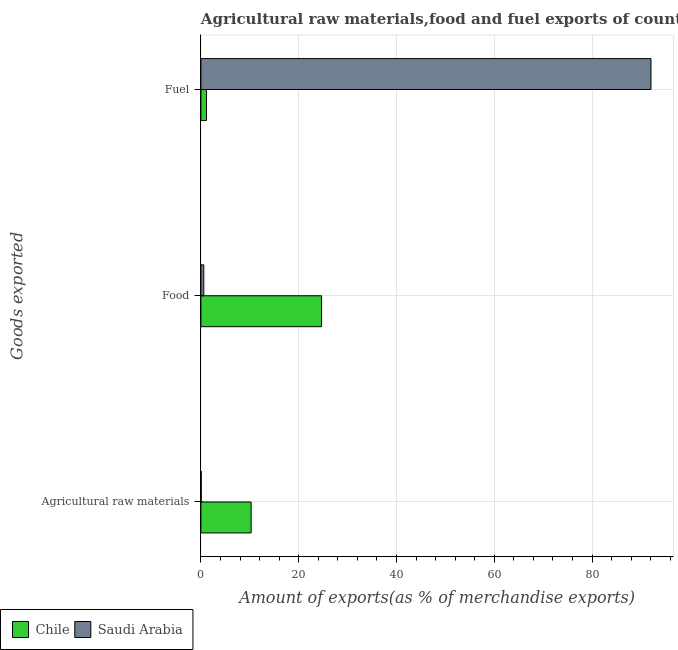How many bars are there on the 3rd tick from the top?
Make the answer very short. 2. How many bars are there on the 2nd tick from the bottom?
Offer a very short reply. 2. What is the label of the 1st group of bars from the top?
Keep it short and to the point. Fuel. What is the percentage of food exports in Saudi Arabia?
Make the answer very short. 0.59. Across all countries, what is the maximum percentage of fuel exports?
Your response must be concise. 92.06. Across all countries, what is the minimum percentage of food exports?
Offer a terse response. 0.59. In which country was the percentage of fuel exports minimum?
Provide a short and direct response. Chile. What is the total percentage of food exports in the graph?
Provide a succinct answer. 25.26. What is the difference between the percentage of raw materials exports in Saudi Arabia and that in Chile?
Offer a terse response. -10.22. What is the difference between the percentage of raw materials exports in Saudi Arabia and the percentage of food exports in Chile?
Ensure brevity in your answer.  -24.62. What is the average percentage of food exports per country?
Offer a terse response. 12.63. What is the difference between the percentage of food exports and percentage of raw materials exports in Chile?
Give a very brief answer. 14.4. In how many countries, is the percentage of fuel exports greater than 76 %?
Provide a short and direct response. 1. What is the ratio of the percentage of food exports in Saudi Arabia to that in Chile?
Ensure brevity in your answer.  0.02. Is the difference between the percentage of food exports in Chile and Saudi Arabia greater than the difference between the percentage of raw materials exports in Chile and Saudi Arabia?
Ensure brevity in your answer.  Yes. What is the difference between the highest and the second highest percentage of fuel exports?
Offer a very short reply. 90.92. What is the difference between the highest and the lowest percentage of raw materials exports?
Provide a succinct answer. 10.22. Is the sum of the percentage of fuel exports in Saudi Arabia and Chile greater than the maximum percentage of food exports across all countries?
Keep it short and to the point. Yes. What does the 1st bar from the top in Food represents?
Offer a very short reply. Saudi Arabia. What does the 2nd bar from the bottom in Agricultural raw materials represents?
Offer a very short reply. Saudi Arabia. Is it the case that in every country, the sum of the percentage of raw materials exports and percentage of food exports is greater than the percentage of fuel exports?
Provide a short and direct response. No. Are all the bars in the graph horizontal?
Your answer should be very brief. Yes. How many countries are there in the graph?
Keep it short and to the point. 2. Where does the legend appear in the graph?
Your response must be concise. Bottom left. How many legend labels are there?
Ensure brevity in your answer.  2. What is the title of the graph?
Your answer should be very brief. Agricultural raw materials,food and fuel exports of countries in 2000. Does "Trinidad and Tobago" appear as one of the legend labels in the graph?
Keep it short and to the point. No. What is the label or title of the X-axis?
Provide a short and direct response. Amount of exports(as % of merchandise exports). What is the label or title of the Y-axis?
Your answer should be compact. Goods exported. What is the Amount of exports(as % of merchandise exports) in Chile in Agricultural raw materials?
Offer a terse response. 10.27. What is the Amount of exports(as % of merchandise exports) in Saudi Arabia in Agricultural raw materials?
Your answer should be very brief. 0.06. What is the Amount of exports(as % of merchandise exports) of Chile in Food?
Ensure brevity in your answer.  24.68. What is the Amount of exports(as % of merchandise exports) of Saudi Arabia in Food?
Offer a very short reply. 0.59. What is the Amount of exports(as % of merchandise exports) in Chile in Fuel?
Provide a short and direct response. 1.14. What is the Amount of exports(as % of merchandise exports) in Saudi Arabia in Fuel?
Keep it short and to the point. 92.06. Across all Goods exported, what is the maximum Amount of exports(as % of merchandise exports) in Chile?
Your answer should be very brief. 24.68. Across all Goods exported, what is the maximum Amount of exports(as % of merchandise exports) of Saudi Arabia?
Give a very brief answer. 92.06. Across all Goods exported, what is the minimum Amount of exports(as % of merchandise exports) of Chile?
Your response must be concise. 1.14. Across all Goods exported, what is the minimum Amount of exports(as % of merchandise exports) in Saudi Arabia?
Your response must be concise. 0.06. What is the total Amount of exports(as % of merchandise exports) of Chile in the graph?
Keep it short and to the point. 36.09. What is the total Amount of exports(as % of merchandise exports) of Saudi Arabia in the graph?
Provide a succinct answer. 92.7. What is the difference between the Amount of exports(as % of merchandise exports) of Chile in Agricultural raw materials and that in Food?
Offer a very short reply. -14.4. What is the difference between the Amount of exports(as % of merchandise exports) of Saudi Arabia in Agricultural raw materials and that in Food?
Make the answer very short. -0.53. What is the difference between the Amount of exports(as % of merchandise exports) in Chile in Agricultural raw materials and that in Fuel?
Provide a succinct answer. 9.14. What is the difference between the Amount of exports(as % of merchandise exports) of Saudi Arabia in Agricultural raw materials and that in Fuel?
Your answer should be compact. -92. What is the difference between the Amount of exports(as % of merchandise exports) in Chile in Food and that in Fuel?
Your answer should be compact. 23.54. What is the difference between the Amount of exports(as % of merchandise exports) in Saudi Arabia in Food and that in Fuel?
Your response must be concise. -91.47. What is the difference between the Amount of exports(as % of merchandise exports) of Chile in Agricultural raw materials and the Amount of exports(as % of merchandise exports) of Saudi Arabia in Food?
Your answer should be very brief. 9.69. What is the difference between the Amount of exports(as % of merchandise exports) of Chile in Agricultural raw materials and the Amount of exports(as % of merchandise exports) of Saudi Arabia in Fuel?
Offer a very short reply. -81.78. What is the difference between the Amount of exports(as % of merchandise exports) of Chile in Food and the Amount of exports(as % of merchandise exports) of Saudi Arabia in Fuel?
Give a very brief answer. -67.38. What is the average Amount of exports(as % of merchandise exports) of Chile per Goods exported?
Provide a succinct answer. 12.03. What is the average Amount of exports(as % of merchandise exports) of Saudi Arabia per Goods exported?
Ensure brevity in your answer.  30.9. What is the difference between the Amount of exports(as % of merchandise exports) in Chile and Amount of exports(as % of merchandise exports) in Saudi Arabia in Agricultural raw materials?
Your response must be concise. 10.22. What is the difference between the Amount of exports(as % of merchandise exports) of Chile and Amount of exports(as % of merchandise exports) of Saudi Arabia in Food?
Provide a short and direct response. 24.09. What is the difference between the Amount of exports(as % of merchandise exports) in Chile and Amount of exports(as % of merchandise exports) in Saudi Arabia in Fuel?
Ensure brevity in your answer.  -90.92. What is the ratio of the Amount of exports(as % of merchandise exports) in Chile in Agricultural raw materials to that in Food?
Provide a succinct answer. 0.42. What is the ratio of the Amount of exports(as % of merchandise exports) of Saudi Arabia in Agricultural raw materials to that in Food?
Offer a very short reply. 0.1. What is the ratio of the Amount of exports(as % of merchandise exports) of Chile in Agricultural raw materials to that in Fuel?
Provide a short and direct response. 9.03. What is the ratio of the Amount of exports(as % of merchandise exports) of Saudi Arabia in Agricultural raw materials to that in Fuel?
Offer a very short reply. 0. What is the ratio of the Amount of exports(as % of merchandise exports) in Chile in Food to that in Fuel?
Give a very brief answer. 21.7. What is the ratio of the Amount of exports(as % of merchandise exports) in Saudi Arabia in Food to that in Fuel?
Ensure brevity in your answer.  0.01. What is the difference between the highest and the second highest Amount of exports(as % of merchandise exports) in Chile?
Make the answer very short. 14.4. What is the difference between the highest and the second highest Amount of exports(as % of merchandise exports) of Saudi Arabia?
Your response must be concise. 91.47. What is the difference between the highest and the lowest Amount of exports(as % of merchandise exports) of Chile?
Your response must be concise. 23.54. What is the difference between the highest and the lowest Amount of exports(as % of merchandise exports) of Saudi Arabia?
Your response must be concise. 92. 